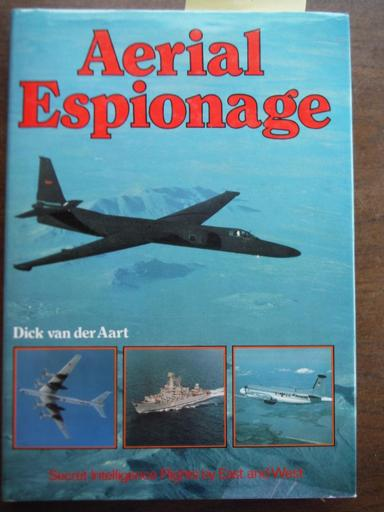What is the title and author of the book mentioned in the image? The book displayed in the image is titled 'Aerial Espionage,' authored by Dick van der Aart. It prominently features a sleek military aircraft on the cover, subtly revealing its thrilling contents about high-stakes intelligence gathering through the skies. 